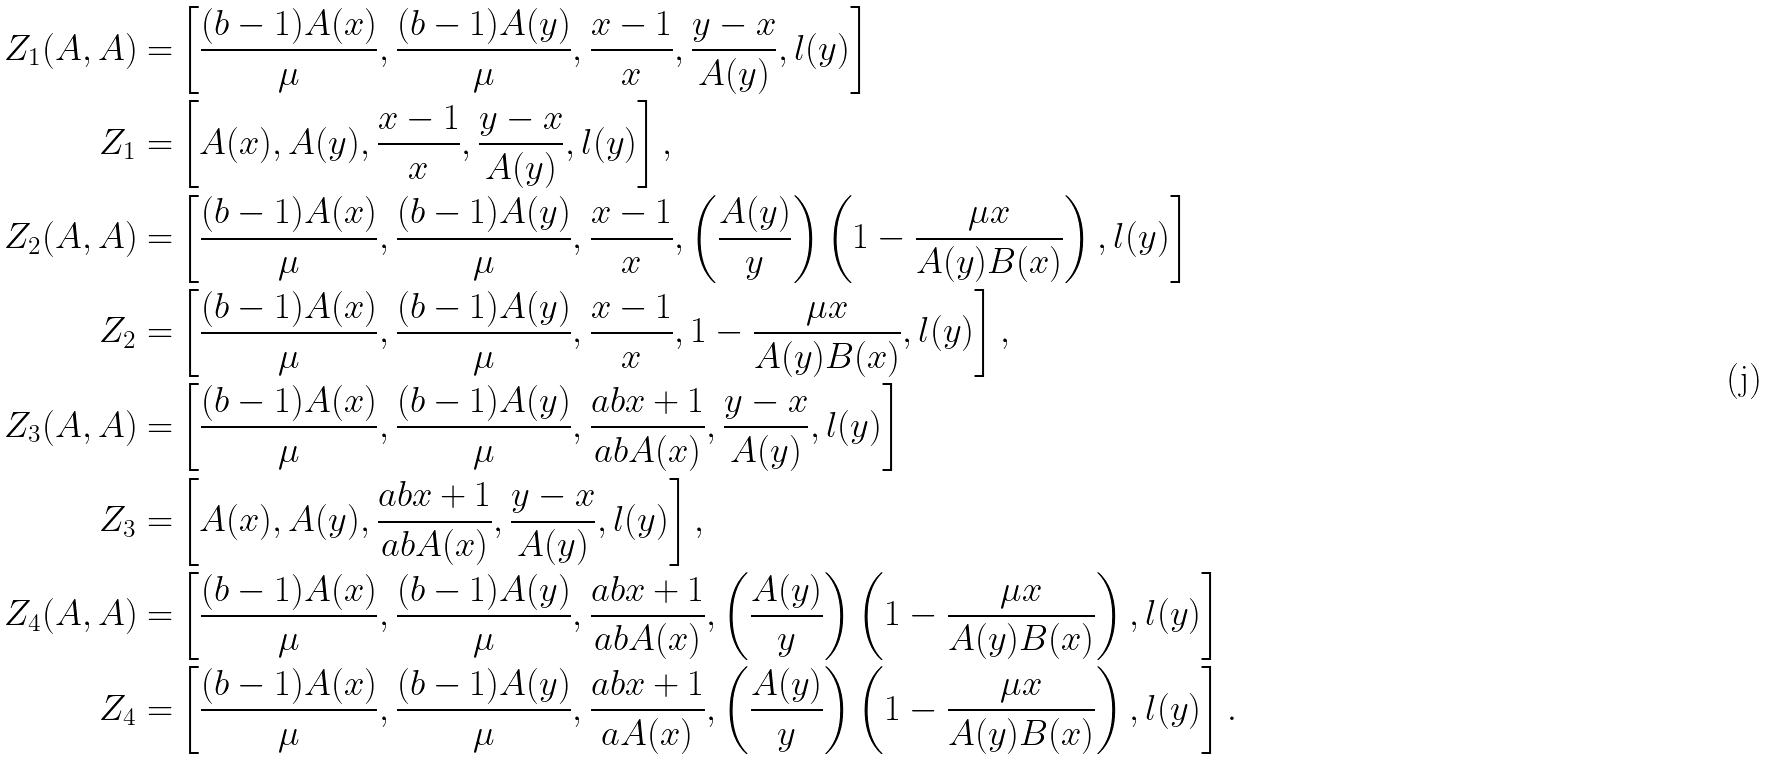<formula> <loc_0><loc_0><loc_500><loc_500>Z _ { 1 } ( A , A ) = & \left [ \frac { ( b - 1 ) A ( x ) } { \mu } , \frac { ( b - 1 ) A ( y ) } { \mu } , \frac { x - 1 } { x } , \frac { y - x } { A ( y ) } , l ( y ) \right ] \\ Z _ { 1 } = & \left [ A ( x ) , A ( y ) , \frac { x - 1 } { x } , \frac { y - x } { A ( y ) } , l ( y ) \right ] , \\ Z _ { 2 } ( A , A ) = & \left [ \frac { ( b - 1 ) A ( x ) } { \mu } , \frac { ( b - 1 ) A ( y ) } { \mu } , \frac { x - 1 } { x } , \left ( \frac { A ( y ) } { y } \right ) \left ( 1 - \frac { \mu x } { A ( y ) B ( x ) } \right ) , l ( y ) \right ] \\ Z _ { 2 } = & \left [ \frac { ( b - 1 ) A ( x ) } { \mu } , \frac { ( b - 1 ) A ( y ) } { \mu } , \frac { x - 1 } { x } , 1 - \frac { \mu x } { A ( y ) B ( x ) } , l ( y ) \right ] , \\ Z _ { 3 } ( A , A ) = & \left [ \frac { ( b - 1 ) A ( x ) } { \mu } , \frac { ( b - 1 ) A ( y ) } { \mu } , \frac { a b x + 1 } { a b A ( x ) } , \frac { y - x } { A ( y ) } , l ( y ) \right ] \\ Z _ { 3 } = & \left [ A ( x ) , A ( y ) , \frac { a b x + 1 } { a b A ( x ) } , \frac { y - x } { A ( y ) } , l ( y ) \right ] , \\ Z _ { 4 } ( A , A ) = & \left [ \frac { ( b - 1 ) A ( x ) } { \mu } , \frac { ( b - 1 ) A ( y ) } { \mu } , \frac { a b x + 1 } { a b A ( x ) } , \left ( \frac { A ( y ) } { y } \right ) \left ( 1 - \frac { \mu x } { A ( y ) B ( x ) } \right ) , l ( y ) \right ] \\ Z _ { 4 } = & \left [ \frac { ( b - 1 ) A ( x ) } { \mu } , \frac { ( b - 1 ) A ( y ) } { \mu } , \frac { a b x + 1 } { a A ( x ) } , \left ( \frac { A ( y ) } { y } \right ) \left ( 1 - \frac { \mu x } { A ( y ) B ( x ) } \right ) , l ( y ) \right ] .</formula> 